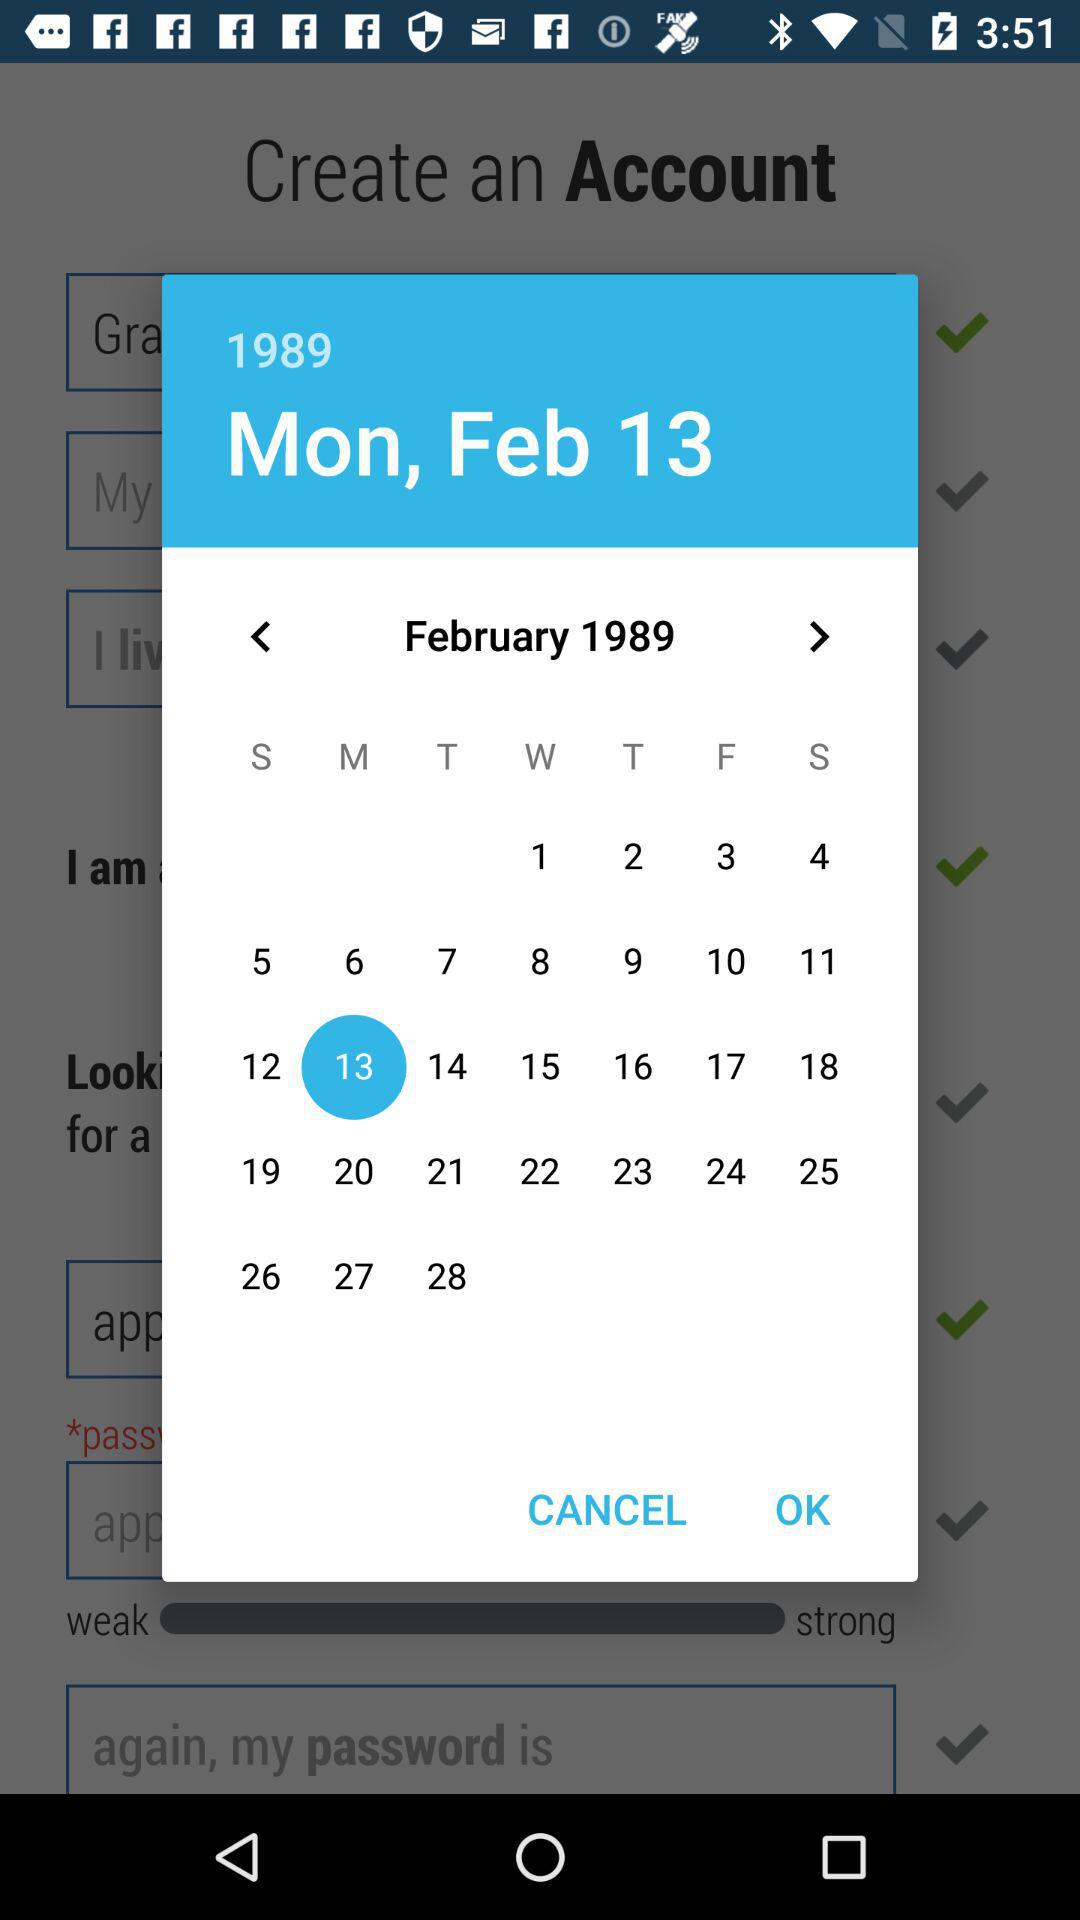What is the selected date and year? The selected date is Monday, February 13 and the year is 1989. 